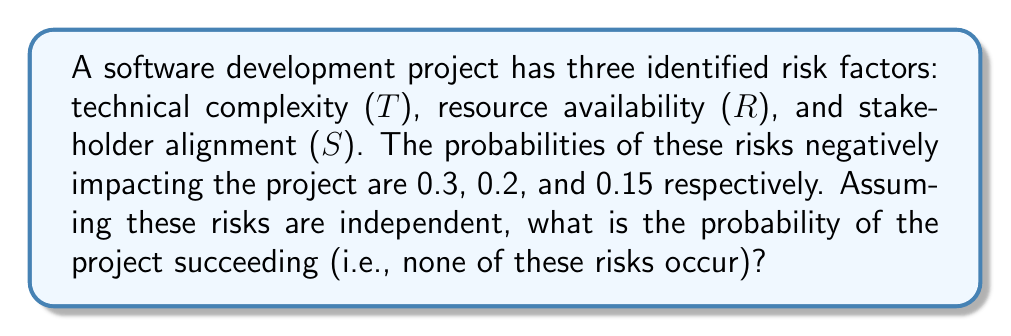Can you answer this question? To solve this problem, we'll follow these steps:

1) First, let's identify what we're looking for. We want the probability of the project succeeding, which means the probability that none of the risks occur.

2) We're given the probabilities of each risk occurring:
   P(T) = 0.3
   P(R) = 0.2
   P(S) = 0.15

3) To find the probability of a risk not occurring, we subtract its probability from 1:
   P(not T) = 1 - 0.3 = 0.7
   P(not R) = 1 - 0.2 = 0.8
   P(not S) = 1 - 0.15 = 0.85

4) Since we're assuming the risks are independent, we can use the multiplication rule of probability. The probability of all events occurring is the product of their individual probabilities:

   $$P(\text{success}) = P(\text{not T}) \times P(\text{not R}) \times P(\text{not S})$$

5) Substituting our values:

   $$P(\text{success}) = 0.7 \times 0.8 \times 0.85$$

6) Calculating:

   $$P(\text{success}) = 0.476$$

Therefore, the probability of the project succeeding (none of the risks occurring) is approximately 0.476 or 47.6%.
Answer: 0.476 